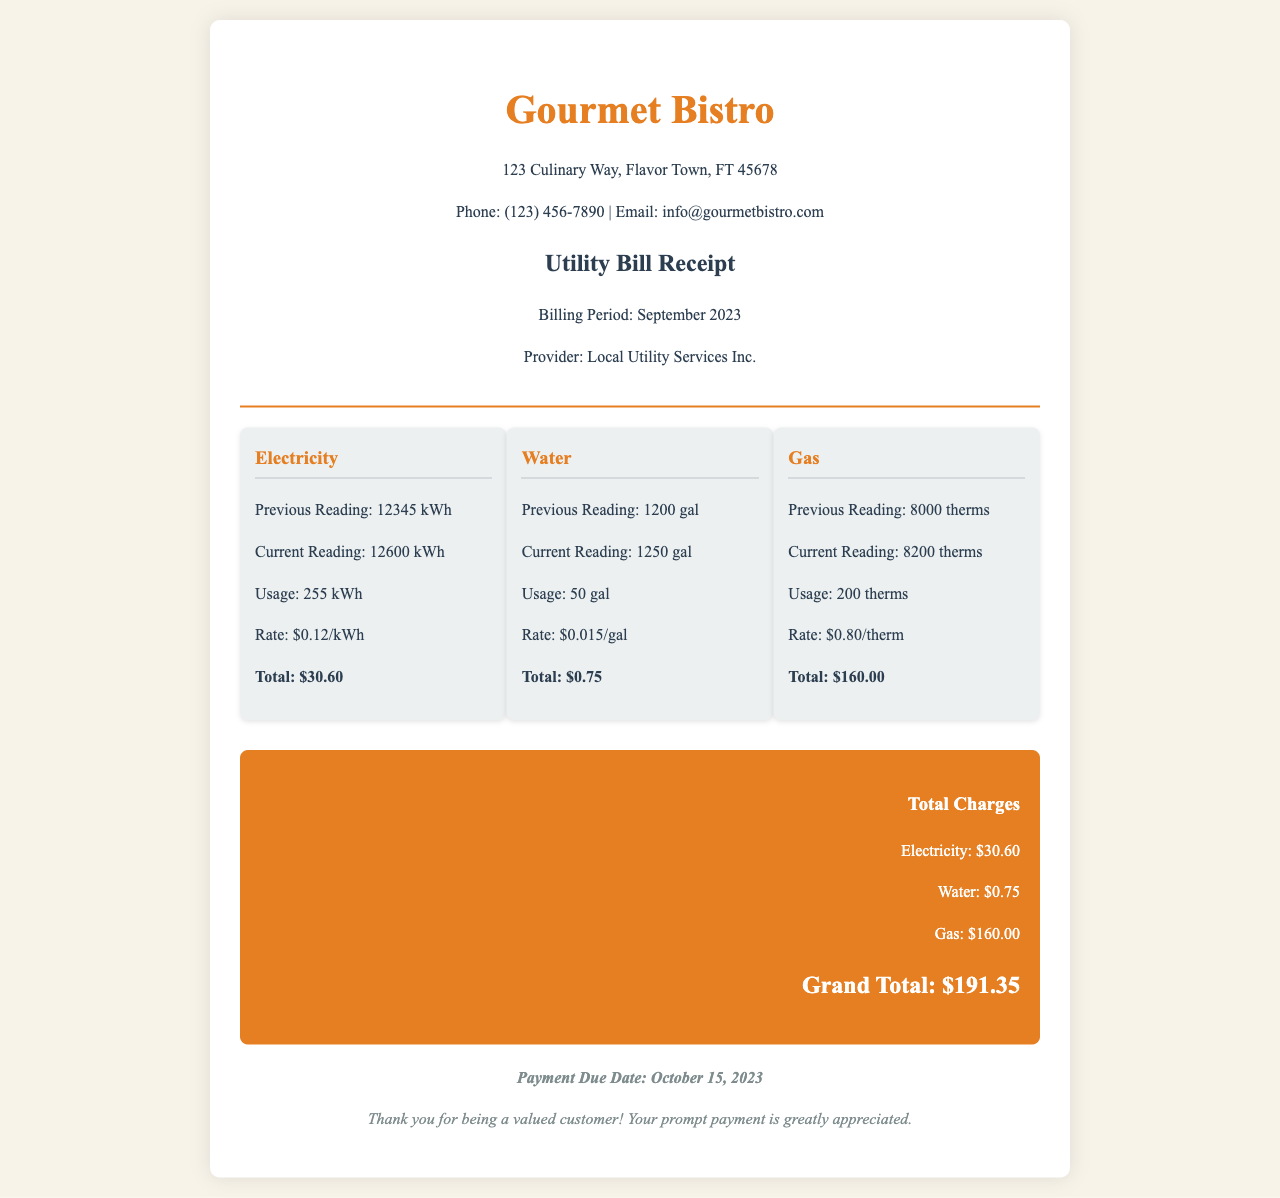What is the billing period? The billing period is clearly mentioned in the document as "September 2023."
Answer: September 2023 What is the address of Gourmet Bistro? The address is listed at the top of the document as "123 Culinary Way, Flavor Town, FT 45678."
Answer: 123 Culinary Way, Flavor Town, FT 45678 What is the total charge for electricity? The total charge for electricity is calculated within the utility breakdown as "$30.60."
Answer: $30.60 How many gallons of water were used? The utility breakdown shows the usage for water as "50 gal."
Answer: 50 gal What is the grand total of the utility bill? The grand total is presented at the bottom of the receipt as "Grand Total: $191.35."
Answer: $191.35 What is the payment due date? The payment due date is specifically noted in the footer as "October 15, 2023."
Answer: October 15, 2023 How much did gas usage cost? Gas usage total is mentioned under the gas section as "$160.00."
Answer: $160.00 What was the current reading for electricity? The current reading for electricity is provided in the document as "12600 kWh."
Answer: 12600 kWh How much was charged per therm of gas? The rate charged for gas per therm is indicated as "$0.80/therm."
Answer: $0.80/therm 